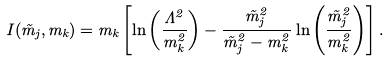<formula> <loc_0><loc_0><loc_500><loc_500>I ( \tilde { m } _ { j } , m _ { k } ) = m _ { k } \left [ \ln \left ( \frac { \Lambda ^ { 2 } } { m _ { k } ^ { 2 } } \right ) - \frac { \tilde { m } _ { j } ^ { 2 } } { \tilde { m } _ { j } ^ { 2 } - m _ { k } ^ { 2 } } \ln \left ( \frac { \tilde { m } _ { j } ^ { 2 } } { m _ { k } ^ { 2 } } \right ) \right ] .</formula> 